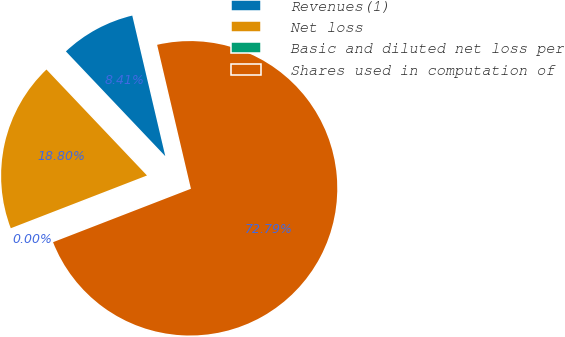<chart> <loc_0><loc_0><loc_500><loc_500><pie_chart><fcel>Revenues(1)<fcel>Net loss<fcel>Basic and diluted net loss per<fcel>Shares used in computation of<nl><fcel>8.41%<fcel>18.8%<fcel>0.0%<fcel>72.79%<nl></chart> 